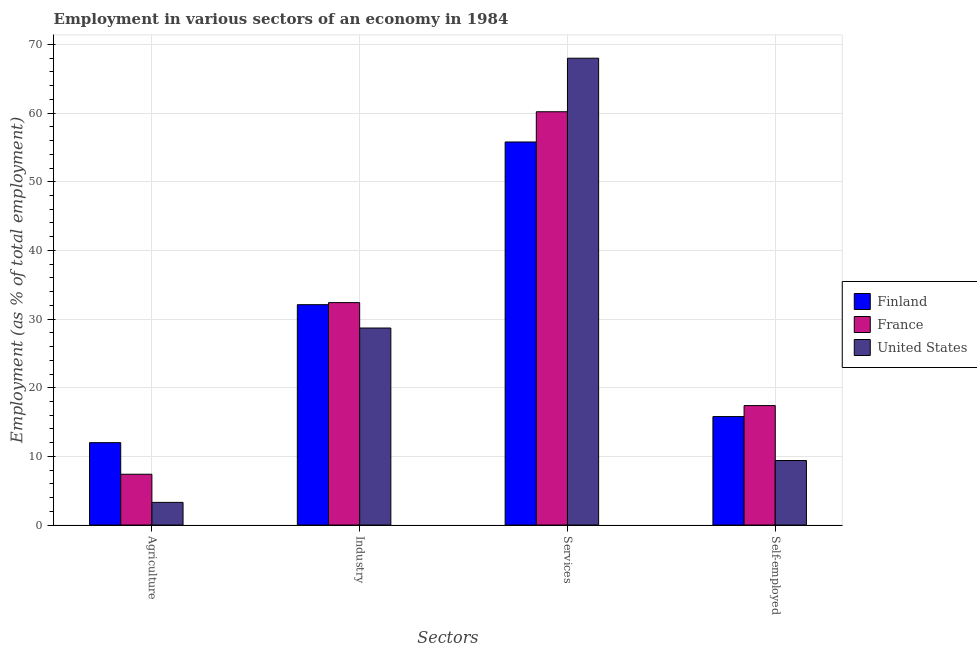How many bars are there on the 2nd tick from the left?
Your answer should be compact. 3. What is the label of the 1st group of bars from the left?
Offer a very short reply. Agriculture. What is the percentage of workers in industry in United States?
Offer a terse response. 28.7. Across all countries, what is the minimum percentage of workers in industry?
Your answer should be compact. 28.7. In which country was the percentage of workers in services maximum?
Provide a short and direct response. United States. In which country was the percentage of workers in services minimum?
Ensure brevity in your answer.  Finland. What is the total percentage of workers in industry in the graph?
Your answer should be compact. 93.2. What is the difference between the percentage of workers in services in France and that in Finland?
Your response must be concise. 4.4. What is the difference between the percentage of workers in agriculture in Finland and the percentage of workers in industry in France?
Give a very brief answer. -20.4. What is the average percentage of workers in agriculture per country?
Offer a very short reply. 7.57. What is the difference between the percentage of self employed workers and percentage of workers in services in Finland?
Your answer should be very brief. -40. In how many countries, is the percentage of self employed workers greater than 20 %?
Provide a succinct answer. 0. What is the ratio of the percentage of workers in agriculture in Finland to that in United States?
Provide a succinct answer. 3.64. Is the difference between the percentage of workers in agriculture in France and Finland greater than the difference between the percentage of workers in services in France and Finland?
Your response must be concise. No. What is the difference between the highest and the second highest percentage of workers in services?
Provide a succinct answer. 7.8. What is the difference between the highest and the lowest percentage of workers in services?
Provide a succinct answer. 12.2. In how many countries, is the percentage of self employed workers greater than the average percentage of self employed workers taken over all countries?
Provide a short and direct response. 2. Is it the case that in every country, the sum of the percentage of workers in services and percentage of workers in agriculture is greater than the sum of percentage of workers in industry and percentage of self employed workers?
Offer a terse response. No. What does the 1st bar from the left in Services represents?
Your response must be concise. Finland. What does the 2nd bar from the right in Industry represents?
Your answer should be compact. France. Is it the case that in every country, the sum of the percentage of workers in agriculture and percentage of workers in industry is greater than the percentage of workers in services?
Provide a succinct answer. No. How many bars are there?
Offer a very short reply. 12. Are all the bars in the graph horizontal?
Provide a succinct answer. No. Are the values on the major ticks of Y-axis written in scientific E-notation?
Offer a very short reply. No. Does the graph contain grids?
Your answer should be compact. Yes. How are the legend labels stacked?
Ensure brevity in your answer.  Vertical. What is the title of the graph?
Your answer should be compact. Employment in various sectors of an economy in 1984. What is the label or title of the X-axis?
Keep it short and to the point. Sectors. What is the label or title of the Y-axis?
Provide a short and direct response. Employment (as % of total employment). What is the Employment (as % of total employment) in France in Agriculture?
Provide a short and direct response. 7.4. What is the Employment (as % of total employment) of United States in Agriculture?
Give a very brief answer. 3.3. What is the Employment (as % of total employment) in Finland in Industry?
Ensure brevity in your answer.  32.1. What is the Employment (as % of total employment) in France in Industry?
Make the answer very short. 32.4. What is the Employment (as % of total employment) in United States in Industry?
Ensure brevity in your answer.  28.7. What is the Employment (as % of total employment) in Finland in Services?
Provide a succinct answer. 55.8. What is the Employment (as % of total employment) of France in Services?
Provide a short and direct response. 60.2. What is the Employment (as % of total employment) of United States in Services?
Make the answer very short. 68. What is the Employment (as % of total employment) of Finland in Self-employed?
Offer a very short reply. 15.8. What is the Employment (as % of total employment) of France in Self-employed?
Your response must be concise. 17.4. What is the Employment (as % of total employment) of United States in Self-employed?
Your answer should be compact. 9.4. Across all Sectors, what is the maximum Employment (as % of total employment) of Finland?
Keep it short and to the point. 55.8. Across all Sectors, what is the maximum Employment (as % of total employment) in France?
Offer a terse response. 60.2. Across all Sectors, what is the minimum Employment (as % of total employment) in France?
Ensure brevity in your answer.  7.4. Across all Sectors, what is the minimum Employment (as % of total employment) of United States?
Your answer should be compact. 3.3. What is the total Employment (as % of total employment) of Finland in the graph?
Your answer should be compact. 115.7. What is the total Employment (as % of total employment) of France in the graph?
Make the answer very short. 117.4. What is the total Employment (as % of total employment) in United States in the graph?
Ensure brevity in your answer.  109.4. What is the difference between the Employment (as % of total employment) in Finland in Agriculture and that in Industry?
Your answer should be compact. -20.1. What is the difference between the Employment (as % of total employment) of France in Agriculture and that in Industry?
Your response must be concise. -25. What is the difference between the Employment (as % of total employment) of United States in Agriculture and that in Industry?
Make the answer very short. -25.4. What is the difference between the Employment (as % of total employment) in Finland in Agriculture and that in Services?
Ensure brevity in your answer.  -43.8. What is the difference between the Employment (as % of total employment) of France in Agriculture and that in Services?
Offer a terse response. -52.8. What is the difference between the Employment (as % of total employment) of United States in Agriculture and that in Services?
Provide a short and direct response. -64.7. What is the difference between the Employment (as % of total employment) of Finland in Agriculture and that in Self-employed?
Give a very brief answer. -3.8. What is the difference between the Employment (as % of total employment) in Finland in Industry and that in Services?
Your answer should be compact. -23.7. What is the difference between the Employment (as % of total employment) of France in Industry and that in Services?
Provide a short and direct response. -27.8. What is the difference between the Employment (as % of total employment) in United States in Industry and that in Services?
Keep it short and to the point. -39.3. What is the difference between the Employment (as % of total employment) of Finland in Industry and that in Self-employed?
Ensure brevity in your answer.  16.3. What is the difference between the Employment (as % of total employment) of France in Industry and that in Self-employed?
Offer a very short reply. 15. What is the difference between the Employment (as % of total employment) of United States in Industry and that in Self-employed?
Ensure brevity in your answer.  19.3. What is the difference between the Employment (as % of total employment) of Finland in Services and that in Self-employed?
Give a very brief answer. 40. What is the difference between the Employment (as % of total employment) in France in Services and that in Self-employed?
Provide a short and direct response. 42.8. What is the difference between the Employment (as % of total employment) of United States in Services and that in Self-employed?
Your response must be concise. 58.6. What is the difference between the Employment (as % of total employment) of Finland in Agriculture and the Employment (as % of total employment) of France in Industry?
Your answer should be compact. -20.4. What is the difference between the Employment (as % of total employment) in Finland in Agriculture and the Employment (as % of total employment) in United States in Industry?
Offer a terse response. -16.7. What is the difference between the Employment (as % of total employment) in France in Agriculture and the Employment (as % of total employment) in United States in Industry?
Ensure brevity in your answer.  -21.3. What is the difference between the Employment (as % of total employment) of Finland in Agriculture and the Employment (as % of total employment) of France in Services?
Provide a short and direct response. -48.2. What is the difference between the Employment (as % of total employment) in Finland in Agriculture and the Employment (as % of total employment) in United States in Services?
Offer a terse response. -56. What is the difference between the Employment (as % of total employment) of France in Agriculture and the Employment (as % of total employment) of United States in Services?
Keep it short and to the point. -60.6. What is the difference between the Employment (as % of total employment) in Finland in Agriculture and the Employment (as % of total employment) in France in Self-employed?
Make the answer very short. -5.4. What is the difference between the Employment (as % of total employment) in Finland in Agriculture and the Employment (as % of total employment) in United States in Self-employed?
Your response must be concise. 2.6. What is the difference between the Employment (as % of total employment) of Finland in Industry and the Employment (as % of total employment) of France in Services?
Make the answer very short. -28.1. What is the difference between the Employment (as % of total employment) of Finland in Industry and the Employment (as % of total employment) of United States in Services?
Make the answer very short. -35.9. What is the difference between the Employment (as % of total employment) in France in Industry and the Employment (as % of total employment) in United States in Services?
Ensure brevity in your answer.  -35.6. What is the difference between the Employment (as % of total employment) in Finland in Industry and the Employment (as % of total employment) in France in Self-employed?
Provide a short and direct response. 14.7. What is the difference between the Employment (as % of total employment) in Finland in Industry and the Employment (as % of total employment) in United States in Self-employed?
Ensure brevity in your answer.  22.7. What is the difference between the Employment (as % of total employment) of Finland in Services and the Employment (as % of total employment) of France in Self-employed?
Keep it short and to the point. 38.4. What is the difference between the Employment (as % of total employment) in Finland in Services and the Employment (as % of total employment) in United States in Self-employed?
Your answer should be very brief. 46.4. What is the difference between the Employment (as % of total employment) of France in Services and the Employment (as % of total employment) of United States in Self-employed?
Offer a very short reply. 50.8. What is the average Employment (as % of total employment) of Finland per Sectors?
Provide a succinct answer. 28.93. What is the average Employment (as % of total employment) in France per Sectors?
Provide a short and direct response. 29.35. What is the average Employment (as % of total employment) of United States per Sectors?
Your answer should be very brief. 27.35. What is the difference between the Employment (as % of total employment) in France and Employment (as % of total employment) in United States in Agriculture?
Your answer should be compact. 4.1. What is the difference between the Employment (as % of total employment) of Finland and Employment (as % of total employment) of France in Industry?
Your answer should be compact. -0.3. What is the difference between the Employment (as % of total employment) in Finland and Employment (as % of total employment) in United States in Industry?
Offer a terse response. 3.4. What is the difference between the Employment (as % of total employment) in France and Employment (as % of total employment) in United States in Industry?
Provide a short and direct response. 3.7. What is the difference between the Employment (as % of total employment) in Finland and Employment (as % of total employment) in United States in Services?
Make the answer very short. -12.2. What is the difference between the Employment (as % of total employment) of France and Employment (as % of total employment) of United States in Services?
Offer a terse response. -7.8. What is the difference between the Employment (as % of total employment) of Finland and Employment (as % of total employment) of France in Self-employed?
Your answer should be very brief. -1.6. What is the difference between the Employment (as % of total employment) in France and Employment (as % of total employment) in United States in Self-employed?
Offer a terse response. 8. What is the ratio of the Employment (as % of total employment) of Finland in Agriculture to that in Industry?
Offer a very short reply. 0.37. What is the ratio of the Employment (as % of total employment) of France in Agriculture to that in Industry?
Provide a succinct answer. 0.23. What is the ratio of the Employment (as % of total employment) in United States in Agriculture to that in Industry?
Your response must be concise. 0.12. What is the ratio of the Employment (as % of total employment) in Finland in Agriculture to that in Services?
Provide a succinct answer. 0.22. What is the ratio of the Employment (as % of total employment) of France in Agriculture to that in Services?
Ensure brevity in your answer.  0.12. What is the ratio of the Employment (as % of total employment) of United States in Agriculture to that in Services?
Your answer should be very brief. 0.05. What is the ratio of the Employment (as % of total employment) in Finland in Agriculture to that in Self-employed?
Give a very brief answer. 0.76. What is the ratio of the Employment (as % of total employment) of France in Agriculture to that in Self-employed?
Your answer should be very brief. 0.43. What is the ratio of the Employment (as % of total employment) of United States in Agriculture to that in Self-employed?
Your answer should be compact. 0.35. What is the ratio of the Employment (as % of total employment) in Finland in Industry to that in Services?
Offer a terse response. 0.58. What is the ratio of the Employment (as % of total employment) in France in Industry to that in Services?
Give a very brief answer. 0.54. What is the ratio of the Employment (as % of total employment) of United States in Industry to that in Services?
Your answer should be compact. 0.42. What is the ratio of the Employment (as % of total employment) of Finland in Industry to that in Self-employed?
Ensure brevity in your answer.  2.03. What is the ratio of the Employment (as % of total employment) of France in Industry to that in Self-employed?
Give a very brief answer. 1.86. What is the ratio of the Employment (as % of total employment) in United States in Industry to that in Self-employed?
Provide a succinct answer. 3.05. What is the ratio of the Employment (as % of total employment) of Finland in Services to that in Self-employed?
Offer a very short reply. 3.53. What is the ratio of the Employment (as % of total employment) of France in Services to that in Self-employed?
Keep it short and to the point. 3.46. What is the ratio of the Employment (as % of total employment) of United States in Services to that in Self-employed?
Offer a very short reply. 7.23. What is the difference between the highest and the second highest Employment (as % of total employment) of Finland?
Ensure brevity in your answer.  23.7. What is the difference between the highest and the second highest Employment (as % of total employment) of France?
Provide a succinct answer. 27.8. What is the difference between the highest and the second highest Employment (as % of total employment) in United States?
Ensure brevity in your answer.  39.3. What is the difference between the highest and the lowest Employment (as % of total employment) in Finland?
Provide a short and direct response. 43.8. What is the difference between the highest and the lowest Employment (as % of total employment) in France?
Your answer should be compact. 52.8. What is the difference between the highest and the lowest Employment (as % of total employment) in United States?
Make the answer very short. 64.7. 